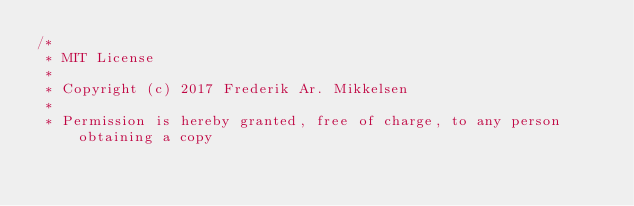<code> <loc_0><loc_0><loc_500><loc_500><_Kotlin_>/*
 * MIT License
 *
 * Copyright (c) 2017 Frederik Ar. Mikkelsen
 *
 * Permission is hereby granted, free of charge, to any person obtaining a copy</code> 